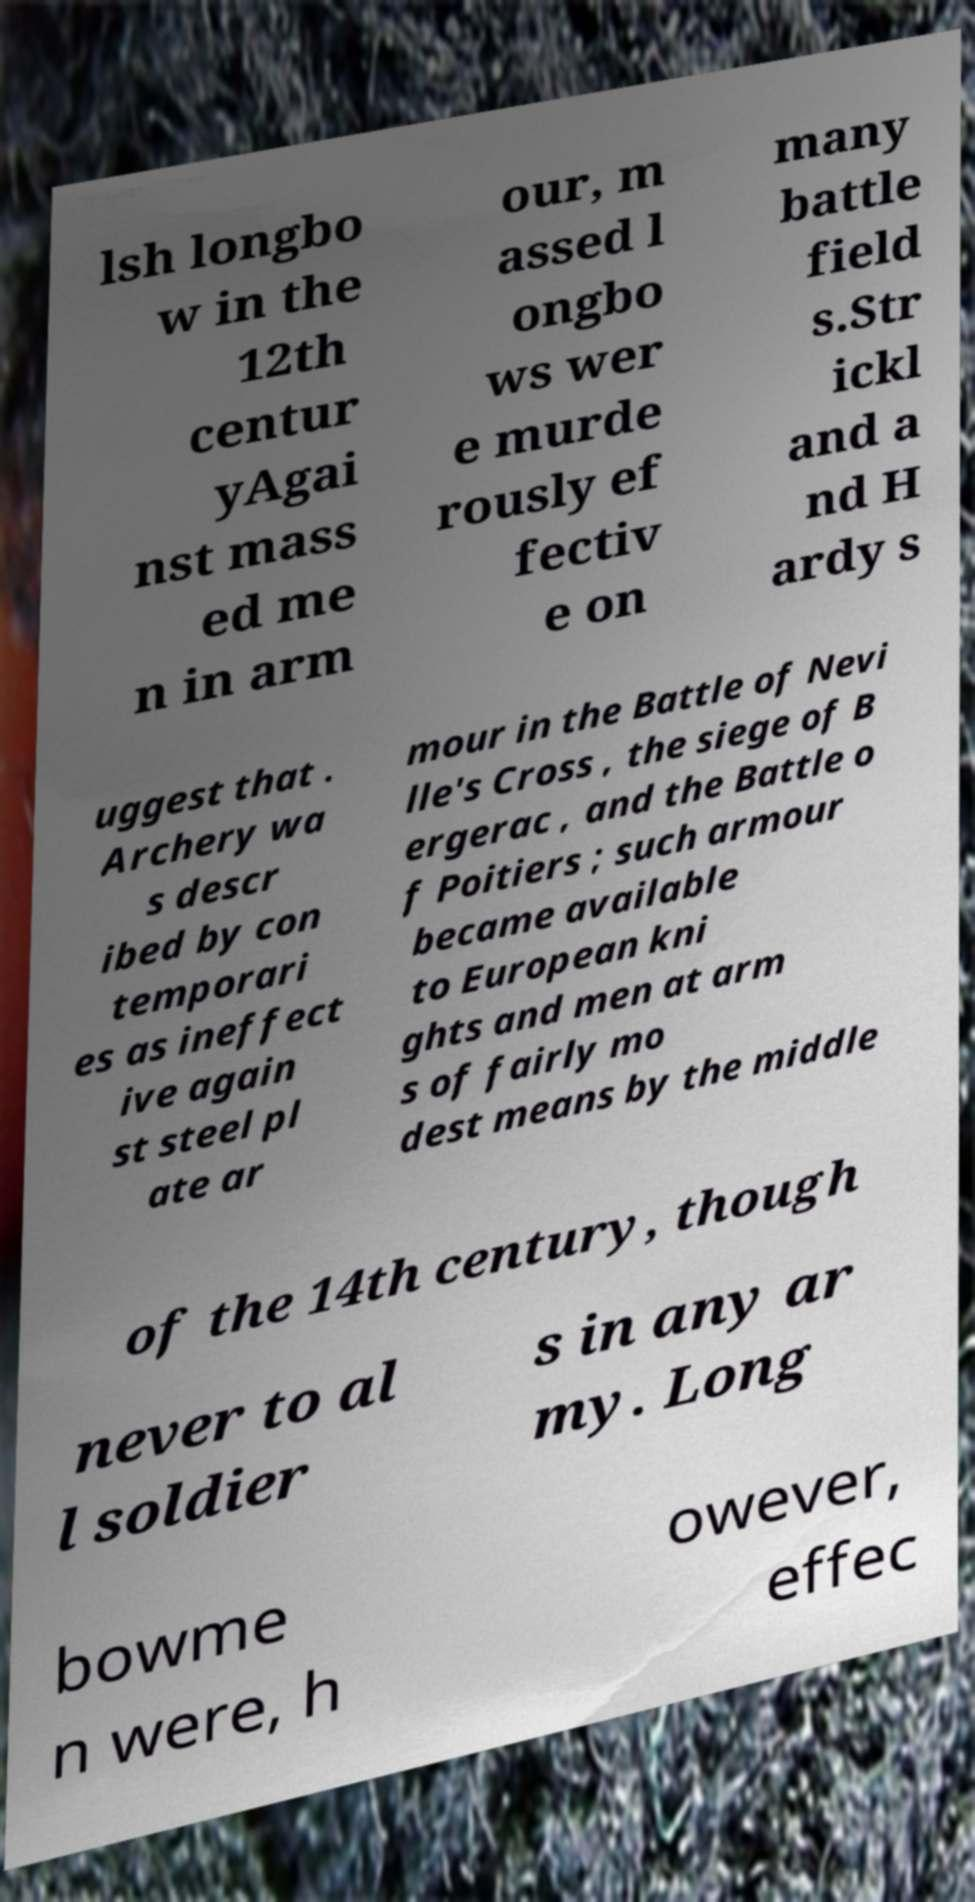There's text embedded in this image that I need extracted. Can you transcribe it verbatim? lsh longbo w in the 12th centur yAgai nst mass ed me n in arm our, m assed l ongbo ws wer e murde rously ef fectiv e on many battle field s.Str ickl and a nd H ardy s uggest that . Archery wa s descr ibed by con temporari es as ineffect ive again st steel pl ate ar mour in the Battle of Nevi lle's Cross , the siege of B ergerac , and the Battle o f Poitiers ; such armour became available to European kni ghts and men at arm s of fairly mo dest means by the middle of the 14th century, though never to al l soldier s in any ar my. Long bowme n were, h owever, effec 